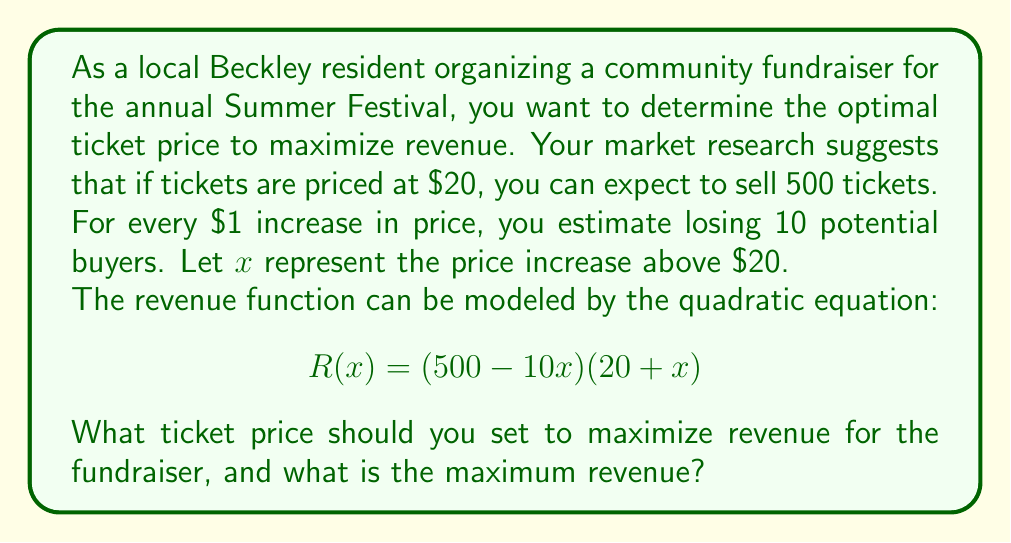Show me your answer to this math problem. Let's approach this step-by-step:

1) First, let's expand the revenue function:
   $$R(x) = (500 - 10x)(20 + x)$$
   $$R(x) = 10000 + 500x - 200x - 10x^2$$
   $$R(x) = -10x^2 + 300x + 10000$$

2) To find the maximum revenue, we need to find the vertex of this parabola. The x-coordinate of the vertex will give us the optimal price increase, and the y-coordinate will give us the maximum revenue.

3) For a quadratic function in the form $ax^2 + bx + c$, the x-coordinate of the vertex is given by $-b/(2a)$.

4) In our case, $a = -10$, $b = 300$, so:
   $$x = -\frac{300}{2(-10)} = -\frac{300}{-20} = 15$$

5) This means the optimal price increase is $15. Since $x$ represents the increase above $20, the optimal ticket price is $20 + $15 = $35.

6) To find the maximum revenue, we plug $x = 15$ into our revenue function:
   $$R(15) = -10(15)^2 + 300(15) + 10000$$
   $$= -2250 + 4500 + 10000 = 12250$$

Therefore, the maximum revenue is $12,250.
Answer: The optimal ticket price is $35, and the maximum revenue is $12,250. 